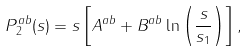<formula> <loc_0><loc_0><loc_500><loc_500>P _ { 2 } ^ { a b } ( s ) = s \left [ A ^ { a b } + B ^ { a b } \ln \left ( \frac { s } { s _ { 1 } } \right ) \right ] ,</formula> 